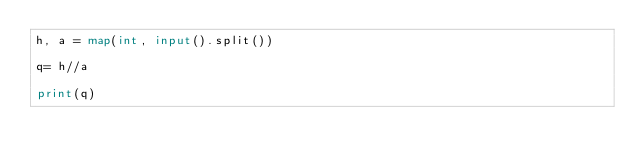Convert code to text. <code><loc_0><loc_0><loc_500><loc_500><_Python_>h, a = map(int, input().split())

q= h//a

print(q)
</code> 